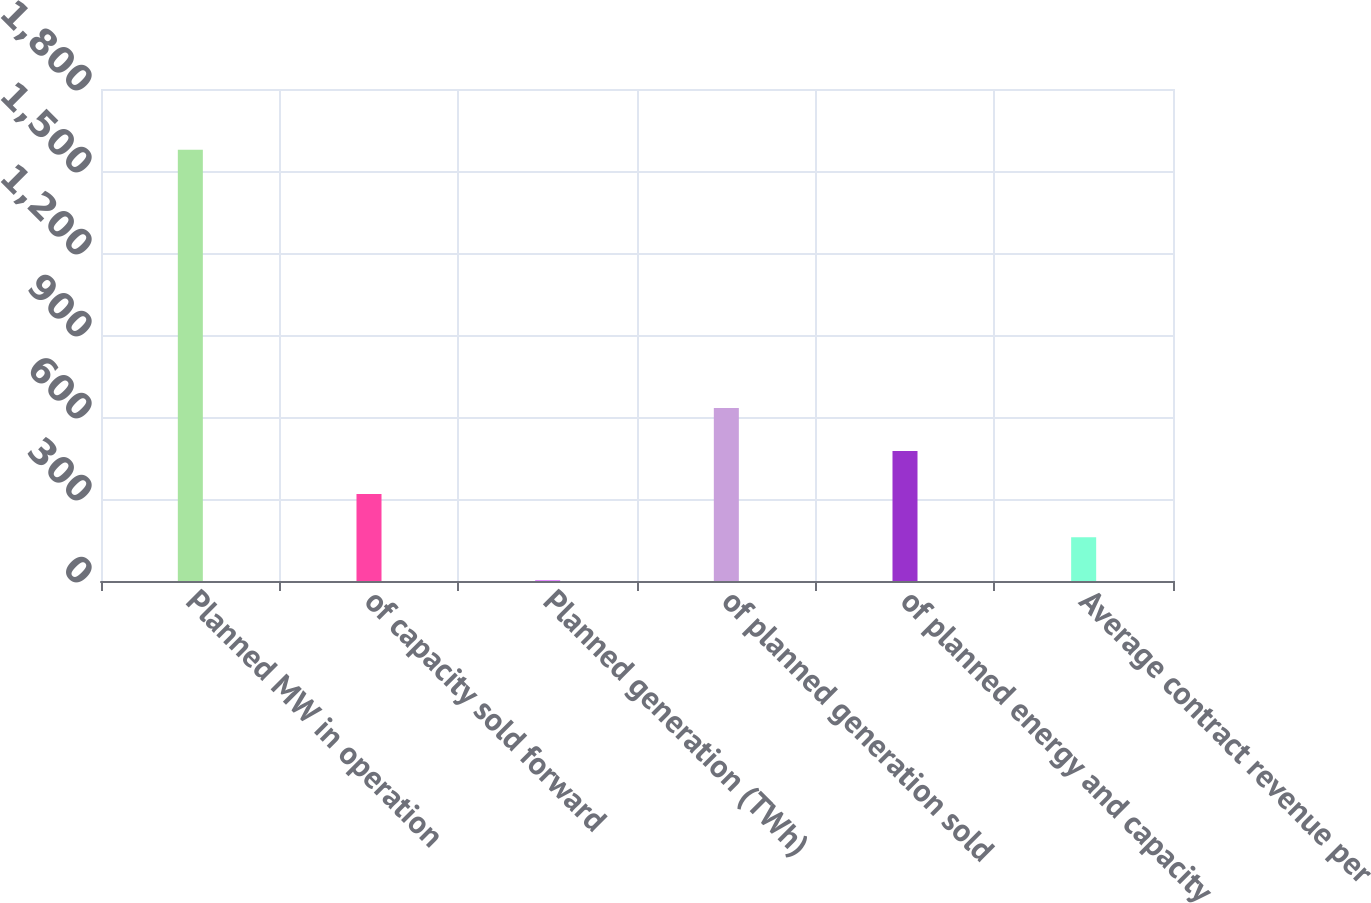<chart> <loc_0><loc_0><loc_500><loc_500><bar_chart><fcel>Planned MW in operation<fcel>of capacity sold forward<fcel>Planned generation (TWh)<fcel>of planned generation sold<fcel>of planned energy and capacity<fcel>Average contract revenue per<nl><fcel>1578<fcel>318<fcel>3<fcel>633<fcel>475.5<fcel>160.5<nl></chart> 